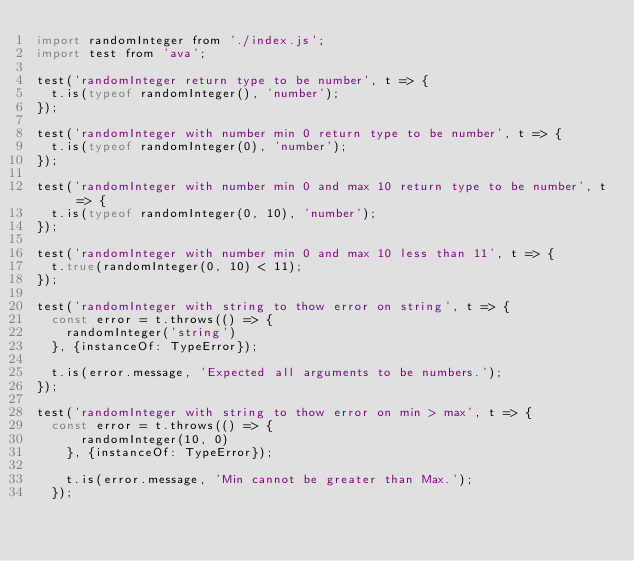Convert code to text. <code><loc_0><loc_0><loc_500><loc_500><_JavaScript_>import randomInteger from './index.js';
import test from 'ava';

test('randomInteger return type to be number', t => {
	t.is(typeof randomInteger(), 'number');
});

test('randomInteger with number min 0 return type to be number', t => {
	t.is(typeof randomInteger(0), 'number');
});

test('randomInteger with number min 0 and max 10 return type to be number', t => {
	t.is(typeof randomInteger(0, 10), 'number');
});

test('randomInteger with number min 0 and max 10 less than 11', t => {
	t.true(randomInteger(0, 10) < 11);
});

test('randomInteger with string to thow error on string', t => {
  const error = t.throws(() => {
		randomInteger('string')
	}, {instanceOf: TypeError});

	t.is(error.message, 'Expected all arguments to be numbers.');
});

test('randomInteger with string to thow error on min > max', t => {
	const error = t.throws(() => {
		  randomInteger(10, 0)
	  }, {instanceOf: TypeError});
  
	  t.is(error.message, 'Min cannot be greater than Max.');
  });</code> 